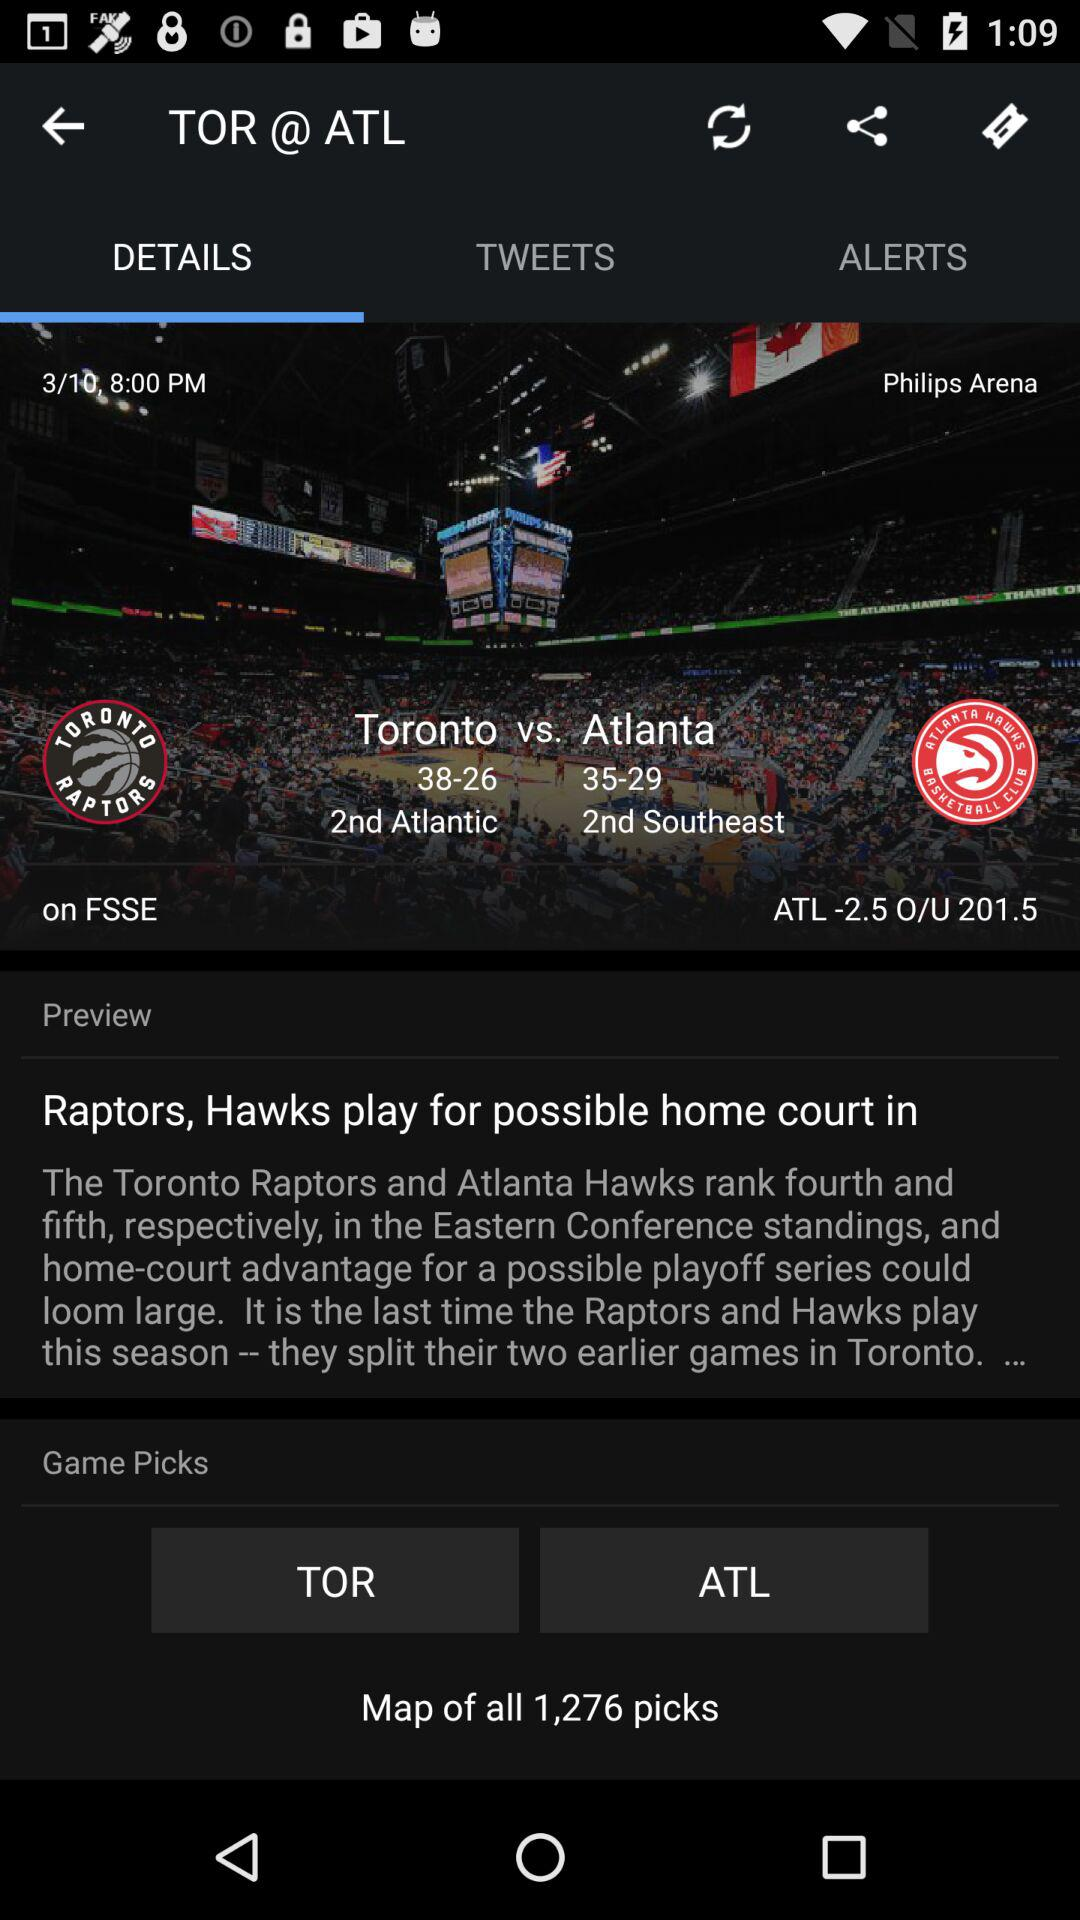What are the teams' names? The teams' names are "Toronto Raptors" and "Atlanta Hawks". 